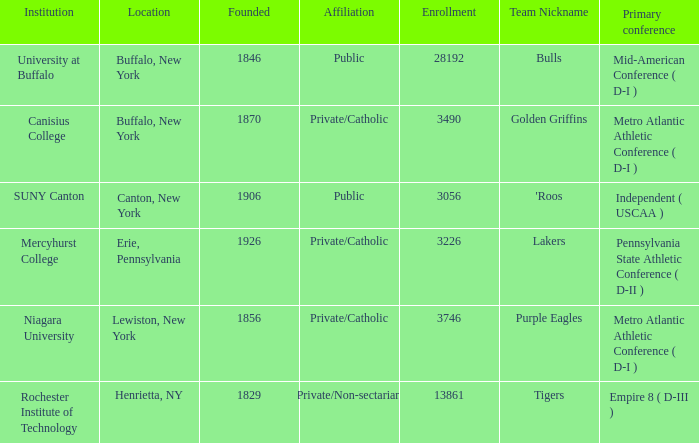What was the admission of the school founded in 1846? 28192.0. 